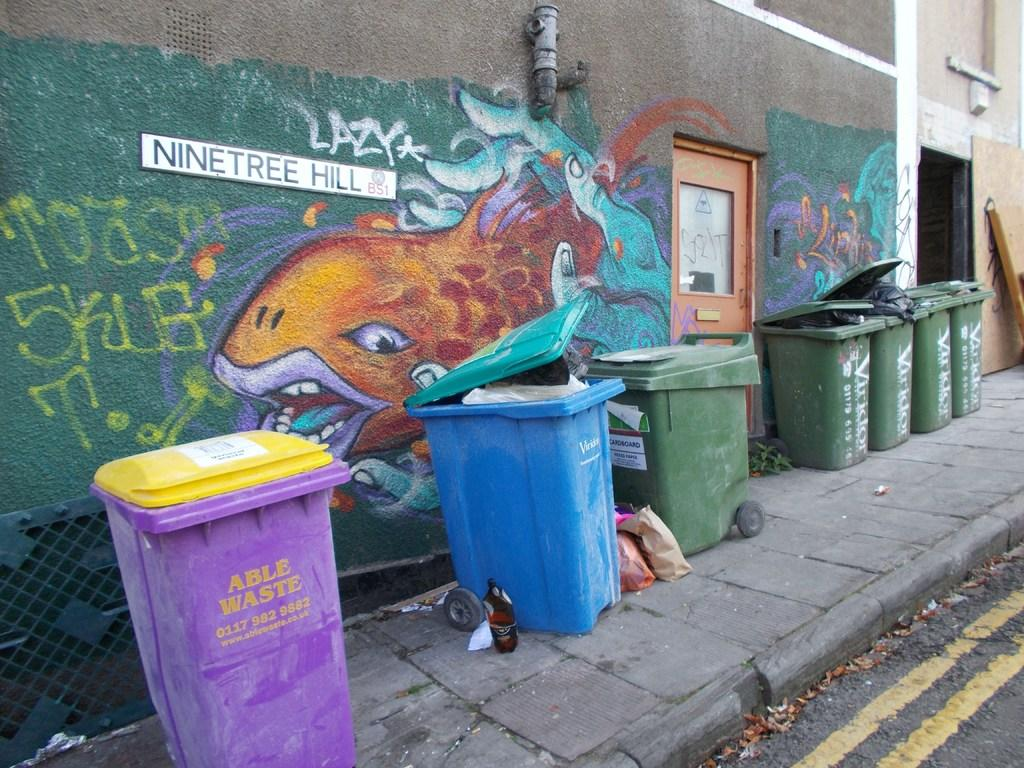<image>
Summarize the visual content of the image. A picture of an orange fish sits on a wall in front of a blue trash can on Nine Tree Hill Ave 